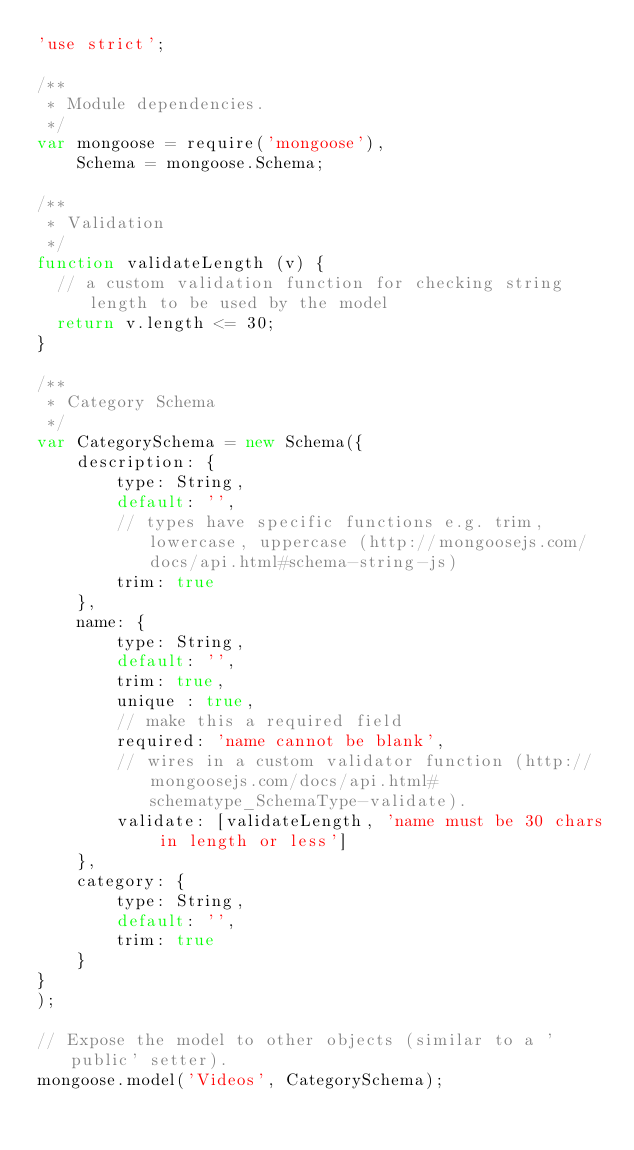Convert code to text. <code><loc_0><loc_0><loc_500><loc_500><_JavaScript_>'use strict';

/**
 * Module dependencies.
 */
var mongoose = require('mongoose'),
    Schema = mongoose.Schema;

/**
 * Validation
 */
function validateLength (v) {
  // a custom validation function for checking string length to be used by the model
  return v.length <= 30;
}

/**
 * Category Schema
 */
var CategorySchema = new Schema({
    description: {
        type: String,
        default: '',
        // types have specific functions e.g. trim, lowercase, uppercase (http://mongoosejs.com/docs/api.html#schema-string-js)
        trim: true
    },
    name: {
        type: String,
        default: '',
        trim: true,     
        unique : true,
        // make this a required field
        required: 'name cannot be blank',
        // wires in a custom validator function (http://mongoosejs.com/docs/api.html#schematype_SchemaType-validate).
        validate: [validateLength, 'name must be 30 chars in length or less']
    },
    category: {
        type: String,
        default: '',
        trim: true
    }
}
);

// Expose the model to other objects (similar to a 'public' setter).
mongoose.model('Videos', CategorySchema);</code> 